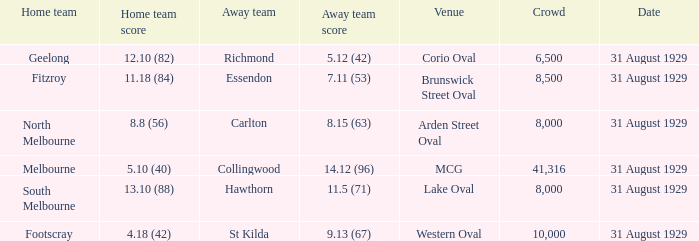What date was the game when the away team was carlton? 31 August 1929. 